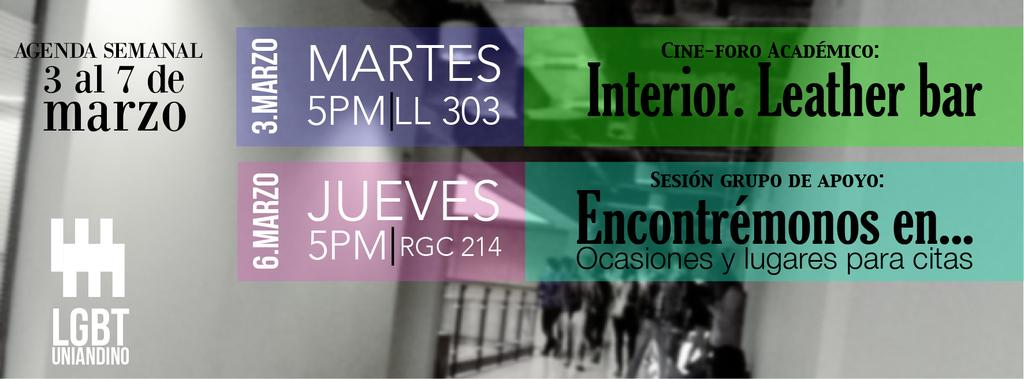What is present in the image that conveys information or ideas? The image contains text. Can you describe the people in the image? There are people in the image. What feature can be seen that provides support or safety? There are railings in the image. What type of structure is visible in the image? There is a wall in the image. What type of honey can be seen dripping from the moon in the image? There is no moon or honey present in the image; it only contains text, people, railings, and a wall. 